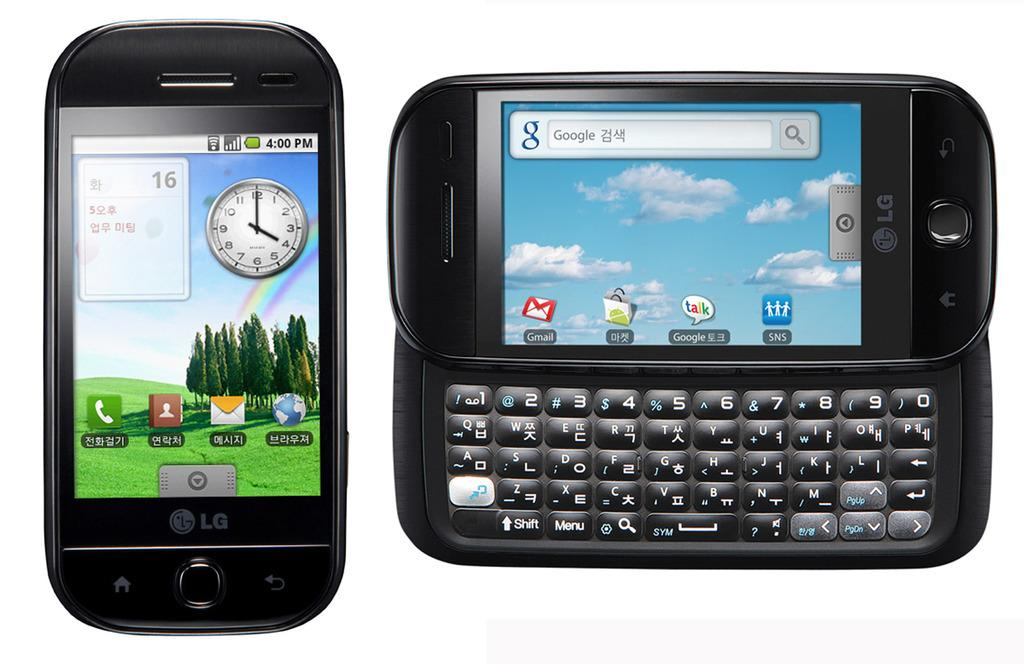<image>
Summarize the visual content of the image. A black LG phone is shown from two different angles. 